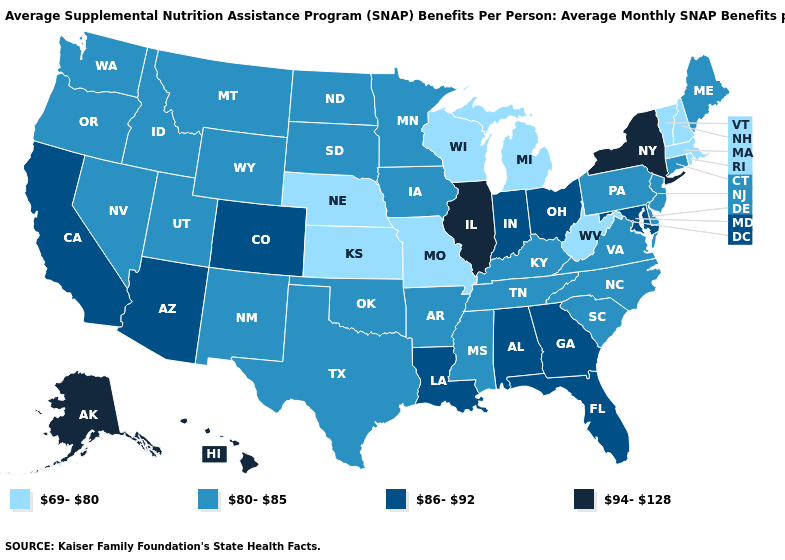What is the highest value in the Northeast ?
Write a very short answer. 94-128. Does the first symbol in the legend represent the smallest category?
Give a very brief answer. Yes. Does South Dakota have the same value as Kansas?
Write a very short answer. No. What is the value of Virginia?
Answer briefly. 80-85. What is the lowest value in the USA?
Keep it brief. 69-80. What is the value of Alaska?
Answer briefly. 94-128. Which states hav the highest value in the MidWest?
Short answer required. Illinois. Does Alaska have the highest value in the USA?
Be succinct. Yes. Does the map have missing data?
Quick response, please. No. Among the states that border Indiana , does Ohio have the highest value?
Be succinct. No. Among the states that border Ohio , does Indiana have the highest value?
Quick response, please. Yes. Does South Carolina have a lower value than Illinois?
Short answer required. Yes. Does New Jersey have the highest value in the USA?
Quick response, please. No. Name the states that have a value in the range 94-128?
Be succinct. Alaska, Hawaii, Illinois, New York. 